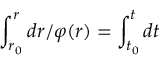<formula> <loc_0><loc_0><loc_500><loc_500>\int _ { r _ { 0 } } ^ { r } d r / \varphi ( r ) = \int _ { t _ { 0 } } ^ { t } d t</formula> 